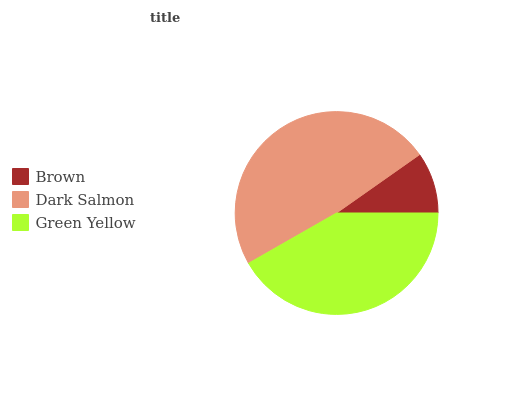Is Brown the minimum?
Answer yes or no. Yes. Is Dark Salmon the maximum?
Answer yes or no. Yes. Is Green Yellow the minimum?
Answer yes or no. No. Is Green Yellow the maximum?
Answer yes or no. No. Is Dark Salmon greater than Green Yellow?
Answer yes or no. Yes. Is Green Yellow less than Dark Salmon?
Answer yes or no. Yes. Is Green Yellow greater than Dark Salmon?
Answer yes or no. No. Is Dark Salmon less than Green Yellow?
Answer yes or no. No. Is Green Yellow the high median?
Answer yes or no. Yes. Is Green Yellow the low median?
Answer yes or no. Yes. Is Dark Salmon the high median?
Answer yes or no. No. Is Brown the low median?
Answer yes or no. No. 